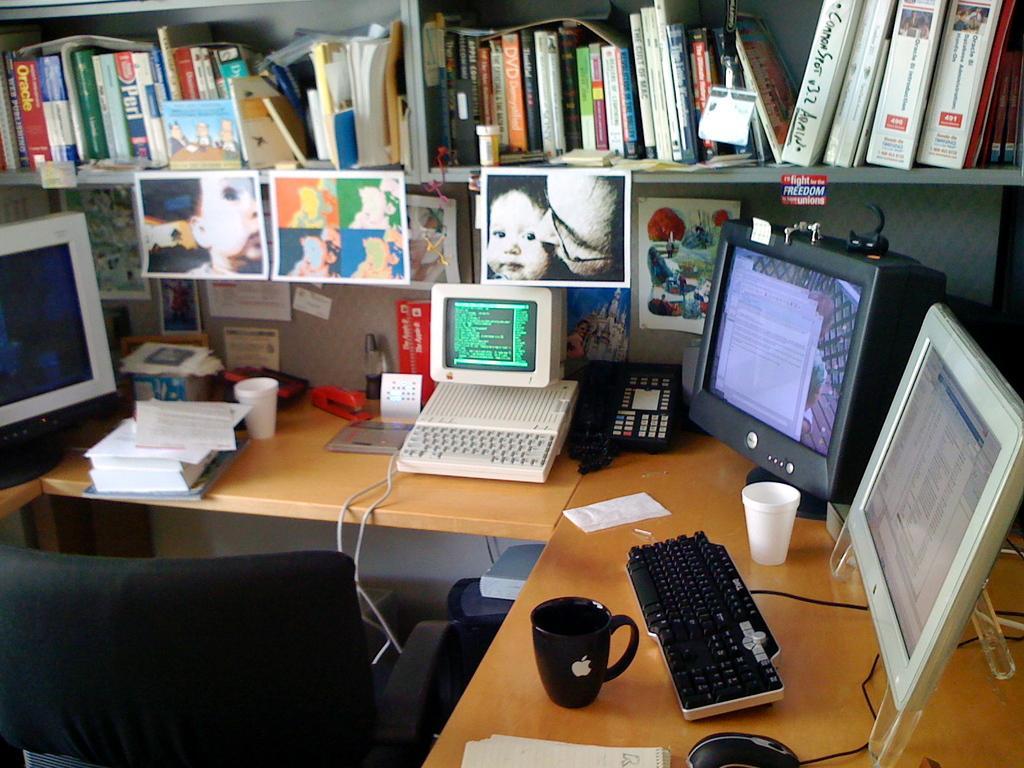Please provide a concise description of this image. In this picture we can see computers on the table. This is the keyboard, and this is mouse. And we can see cups on the table. This is the rack and there are some books on this rack. These are the frames and this is the chair. 